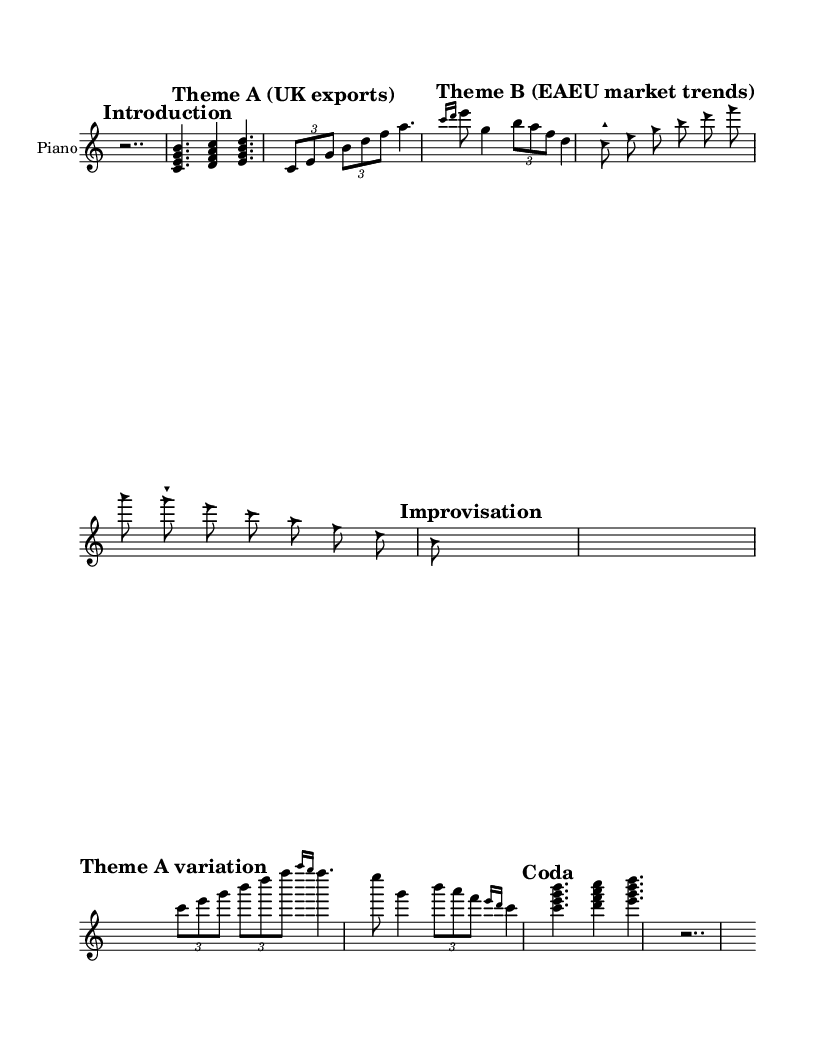What is the time signature of this piece? The time signature is listed right at the start of the music notation. It is indicated as 7/8, which means there are 7 eighth-note beats in each measure.
Answer: 7/8 What is the initial marking of the piece? The initial marking is the "Introduction", which is clear at the beginning of the score and sets the thematic context for the following sections.
Answer: Introduction How many themes are presented in the music? By examining the different marked sections, there are three clear thematic categories identified: Theme A, Theme B, and a variation of Theme A.
Answer: Three What type of notes are used in Theme B? In Theme B, the note heads are described as triangles, which is a specific stylistic choice. This indicates a different approach to the musical notation and interpretation in this section.
Answer: Triangle What is the structure of the improvisation section? The improvisation section has specific markings indicating its start and end, with clear rests used to signify breaks in the music, which suggests a free-form approach. It is presented in a spacious manner without use of a staff.
Answer: Free-form How does Theme A vary in its repeated section? The variation of Theme A includes grace notes and shifts in the overall rhythmic structure, which can be identified in the note presentation and use of tuplets. This indicates a departure from the original theme's rhythm while retaining its core elements.
Answer: Grace notes 